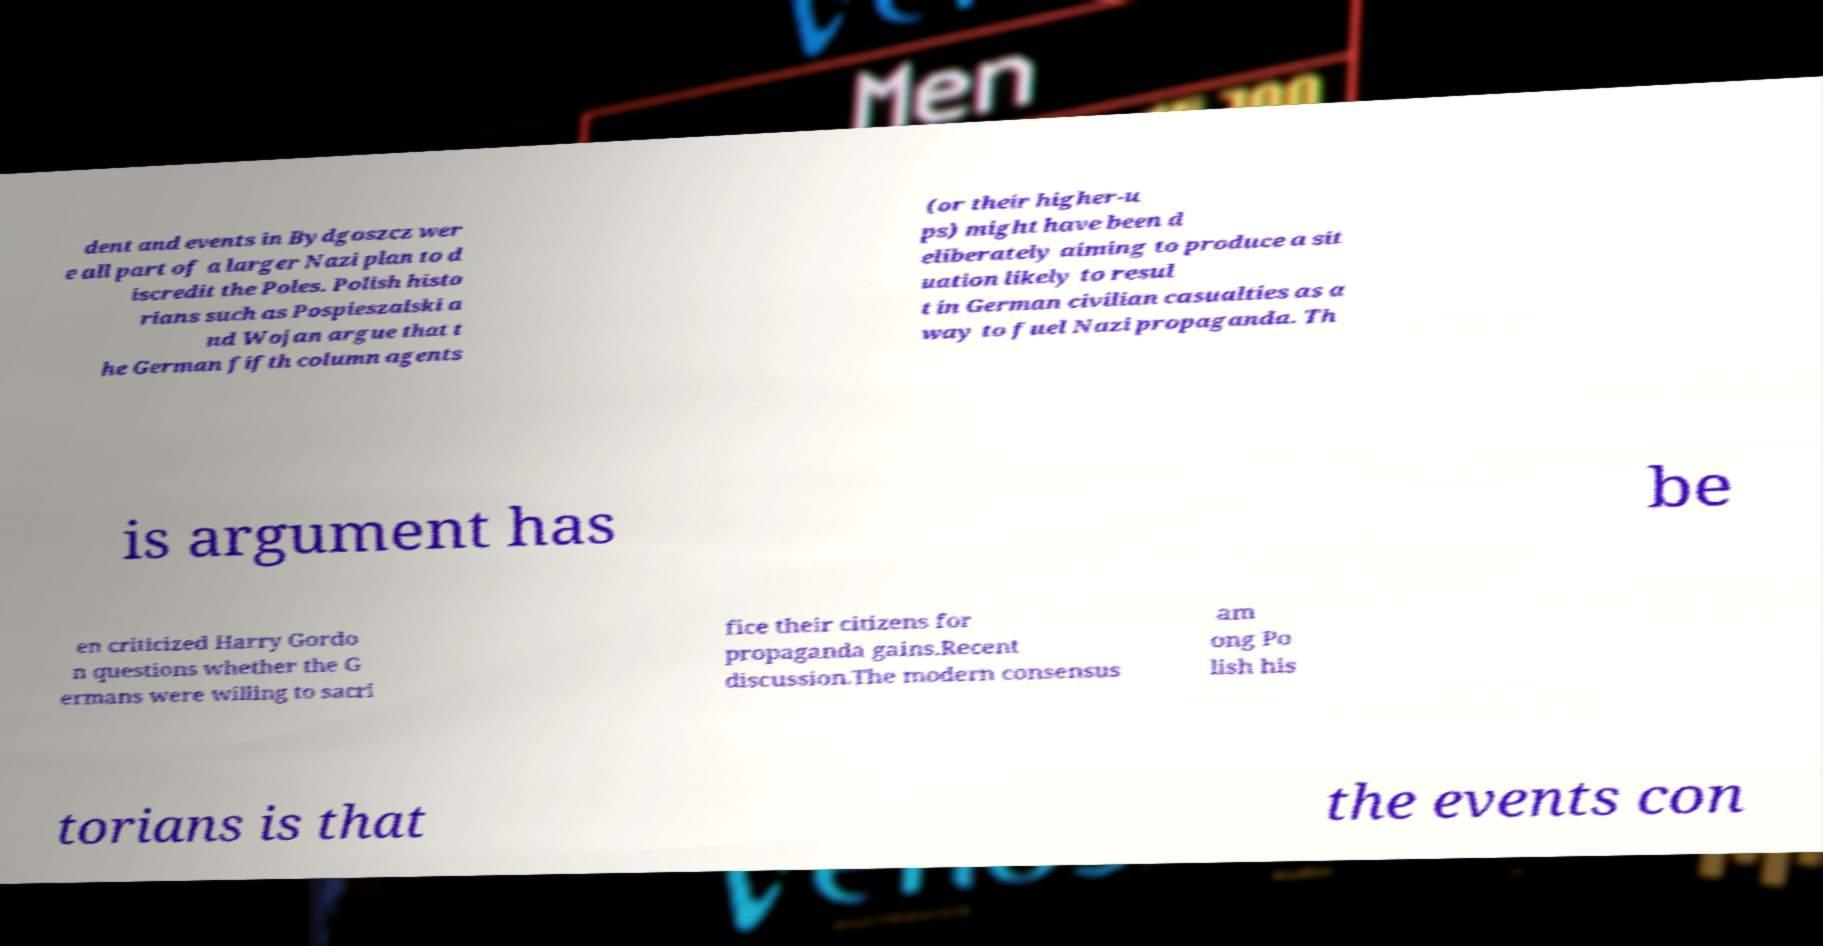For documentation purposes, I need the text within this image transcribed. Could you provide that? dent and events in Bydgoszcz wer e all part of a larger Nazi plan to d iscredit the Poles. Polish histo rians such as Pospieszalski a nd Wojan argue that t he German fifth column agents (or their higher-u ps) might have been d eliberately aiming to produce a sit uation likely to resul t in German civilian casualties as a way to fuel Nazi propaganda. Th is argument has be en criticized Harry Gordo n questions whether the G ermans were willing to sacri fice their citizens for propaganda gains.Recent discussion.The modern consensus am ong Po lish his torians is that the events con 